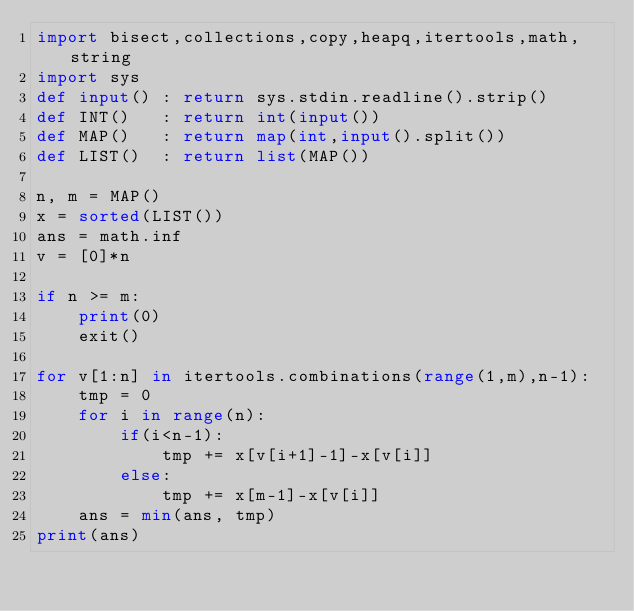<code> <loc_0><loc_0><loc_500><loc_500><_Python_>import bisect,collections,copy,heapq,itertools,math,string
import sys
def input() : return sys.stdin.readline().strip()
def INT()   : return int(input())
def MAP()   : return map(int,input().split())
def LIST()  : return list(MAP())

n, m = MAP()
x = sorted(LIST())
ans = math.inf
v = [0]*n

if n >= m:
    print(0)
    exit()

for v[1:n] in itertools.combinations(range(1,m),n-1):
    tmp = 0
    for i in range(n):
        if(i<n-1):
            tmp += x[v[i+1]-1]-x[v[i]]
        else:
            tmp += x[m-1]-x[v[i]]
    ans = min(ans, tmp)
print(ans)</code> 